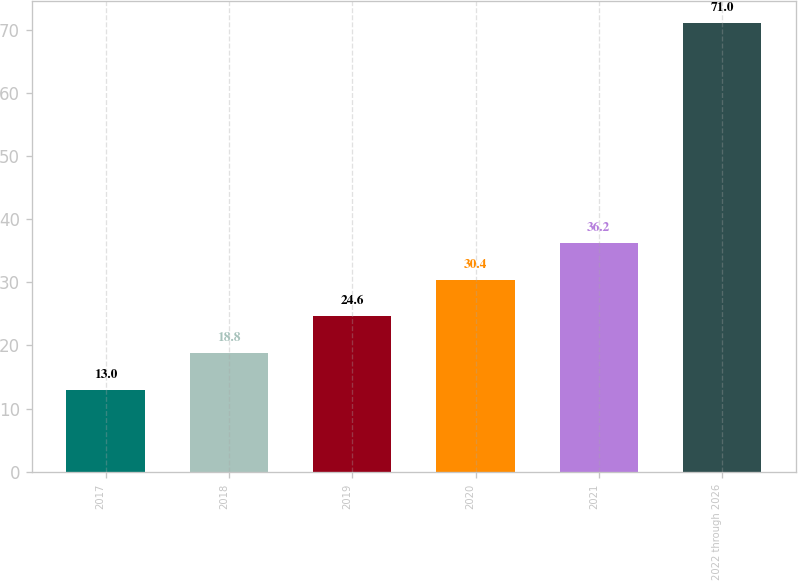Convert chart to OTSL. <chart><loc_0><loc_0><loc_500><loc_500><bar_chart><fcel>2017<fcel>2018<fcel>2019<fcel>2020<fcel>2021<fcel>2022 through 2026<nl><fcel>13<fcel>18.8<fcel>24.6<fcel>30.4<fcel>36.2<fcel>71<nl></chart> 